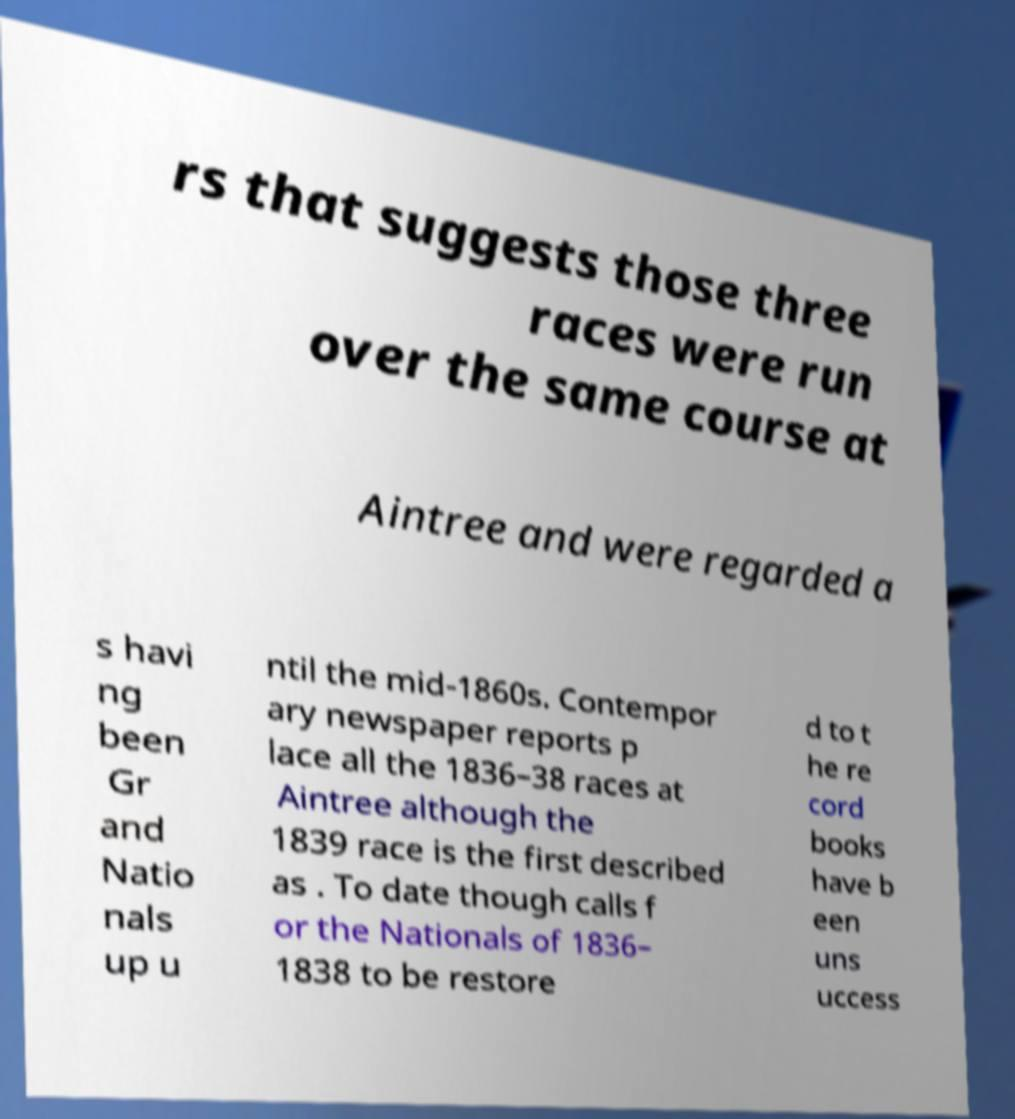I need the written content from this picture converted into text. Can you do that? rs that suggests those three races were run over the same course at Aintree and were regarded a s havi ng been Gr and Natio nals up u ntil the mid-1860s. Contempor ary newspaper reports p lace all the 1836–38 races at Aintree although the 1839 race is the first described as . To date though calls f or the Nationals of 1836– 1838 to be restore d to t he re cord books have b een uns uccess 